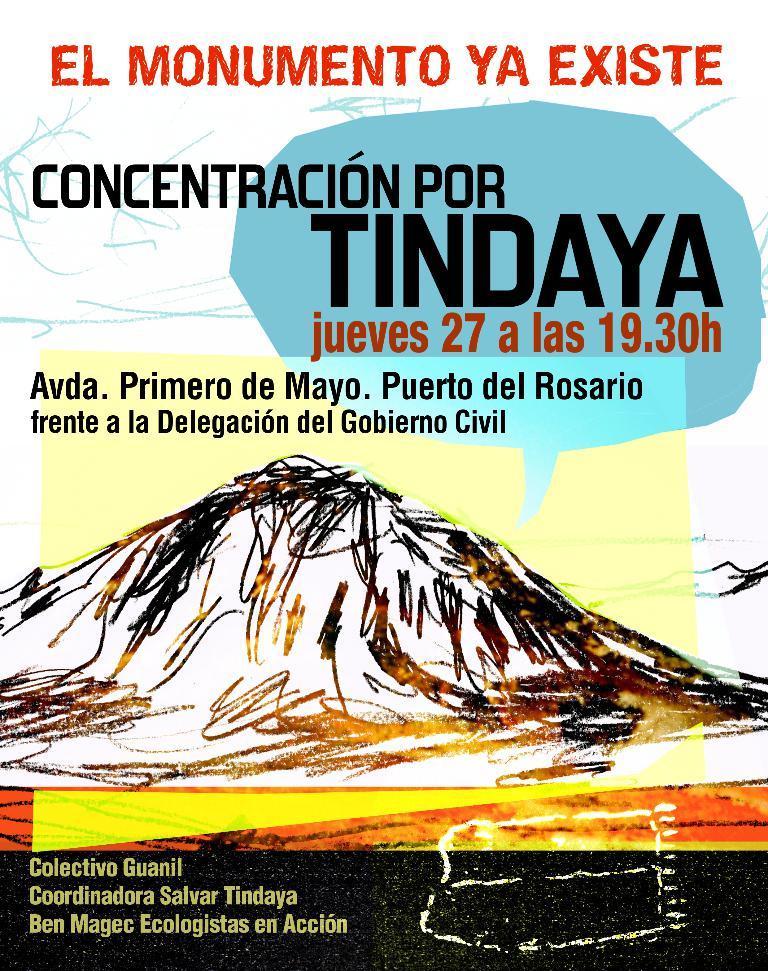Describe this image in one or two sentences. In this picture we can see a poster and on the poster it is written something. 